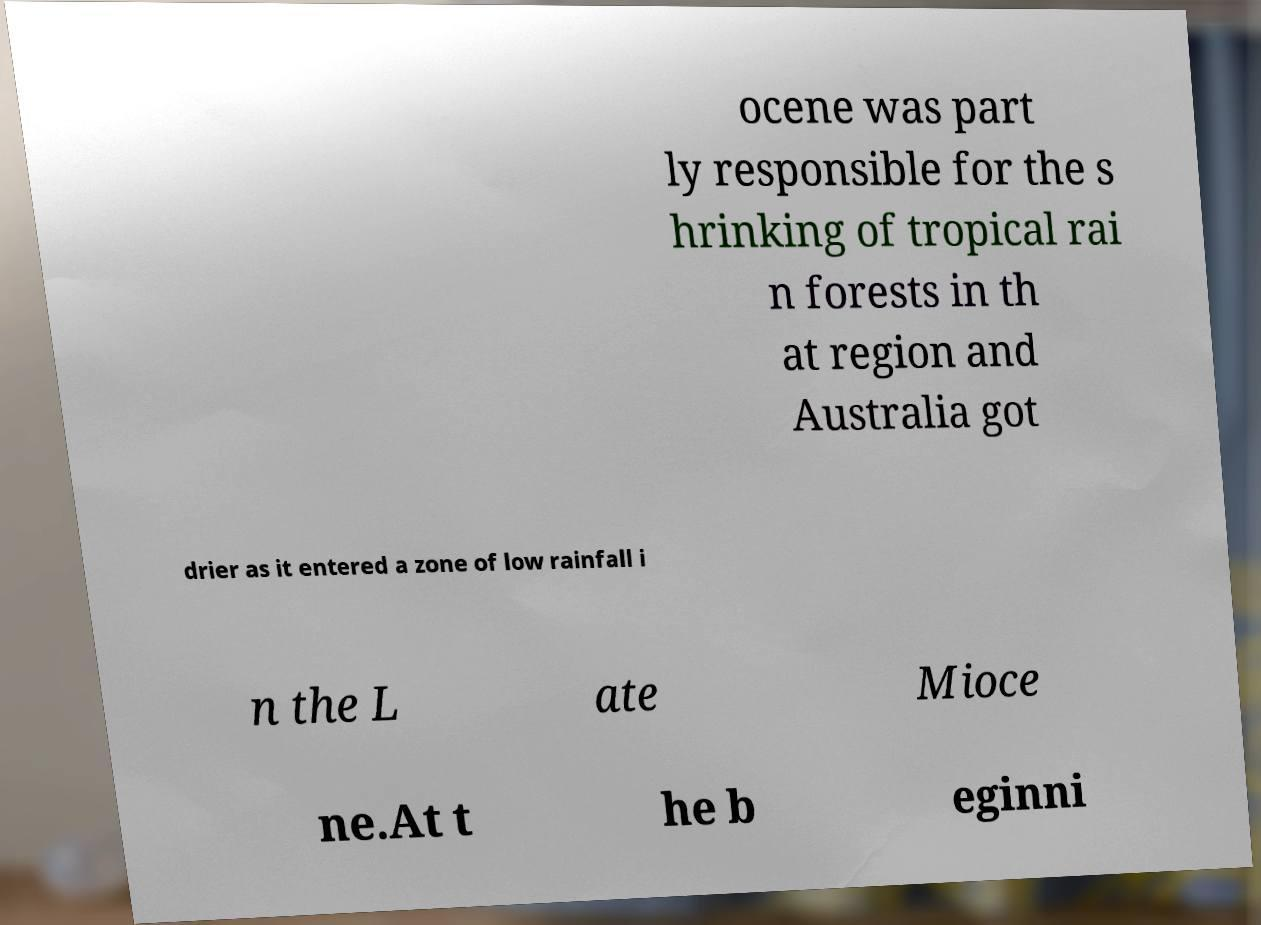I need the written content from this picture converted into text. Can you do that? ocene was part ly responsible for the s hrinking of tropical rai n forests in th at region and Australia got drier as it entered a zone of low rainfall i n the L ate Mioce ne.At t he b eginni 